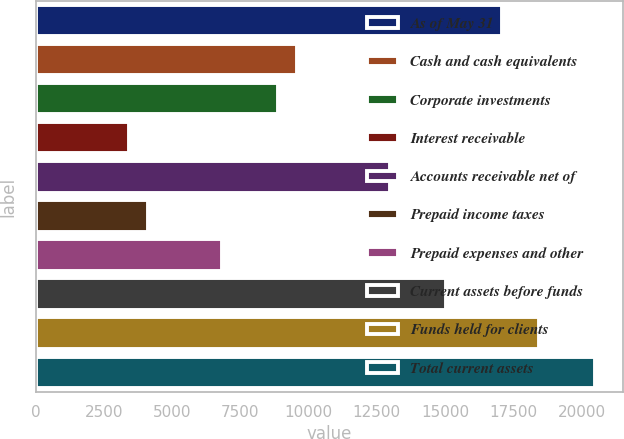Convert chart. <chart><loc_0><loc_0><loc_500><loc_500><bar_chart><fcel>As of May 31<fcel>Cash and cash equivalents<fcel>Corporate investments<fcel>Interest receivable<fcel>Accounts receivable net of<fcel>Prepaid income taxes<fcel>Prepaid expenses and other<fcel>Current assets before funds<fcel>Funds held for clients<fcel>Total current assets<nl><fcel>17078.8<fcel>9565.74<fcel>8882.73<fcel>3418.65<fcel>12980.8<fcel>4101.66<fcel>6833.7<fcel>15029.8<fcel>18444.9<fcel>20493.9<nl></chart> 